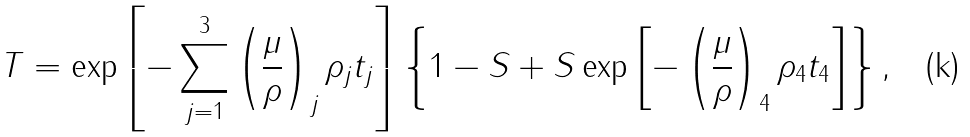<formula> <loc_0><loc_0><loc_500><loc_500>T = \exp \left [ - \sum _ { j = 1 } ^ { 3 } \left ( \frac { \mu } { \rho } \right ) _ { j } \rho _ { j } t _ { j } \right ] \left \{ 1 - S + S \exp \left [ - \left ( \frac { \mu } { \rho } \right ) _ { 4 } \rho _ { 4 } t _ { 4 } \right ] \right \} ,</formula> 